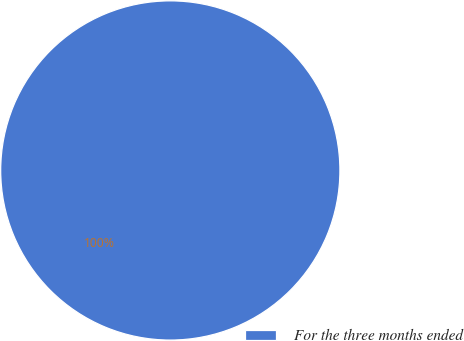Convert chart. <chart><loc_0><loc_0><loc_500><loc_500><pie_chart><fcel>For the three months ended<nl><fcel>100.0%<nl></chart> 